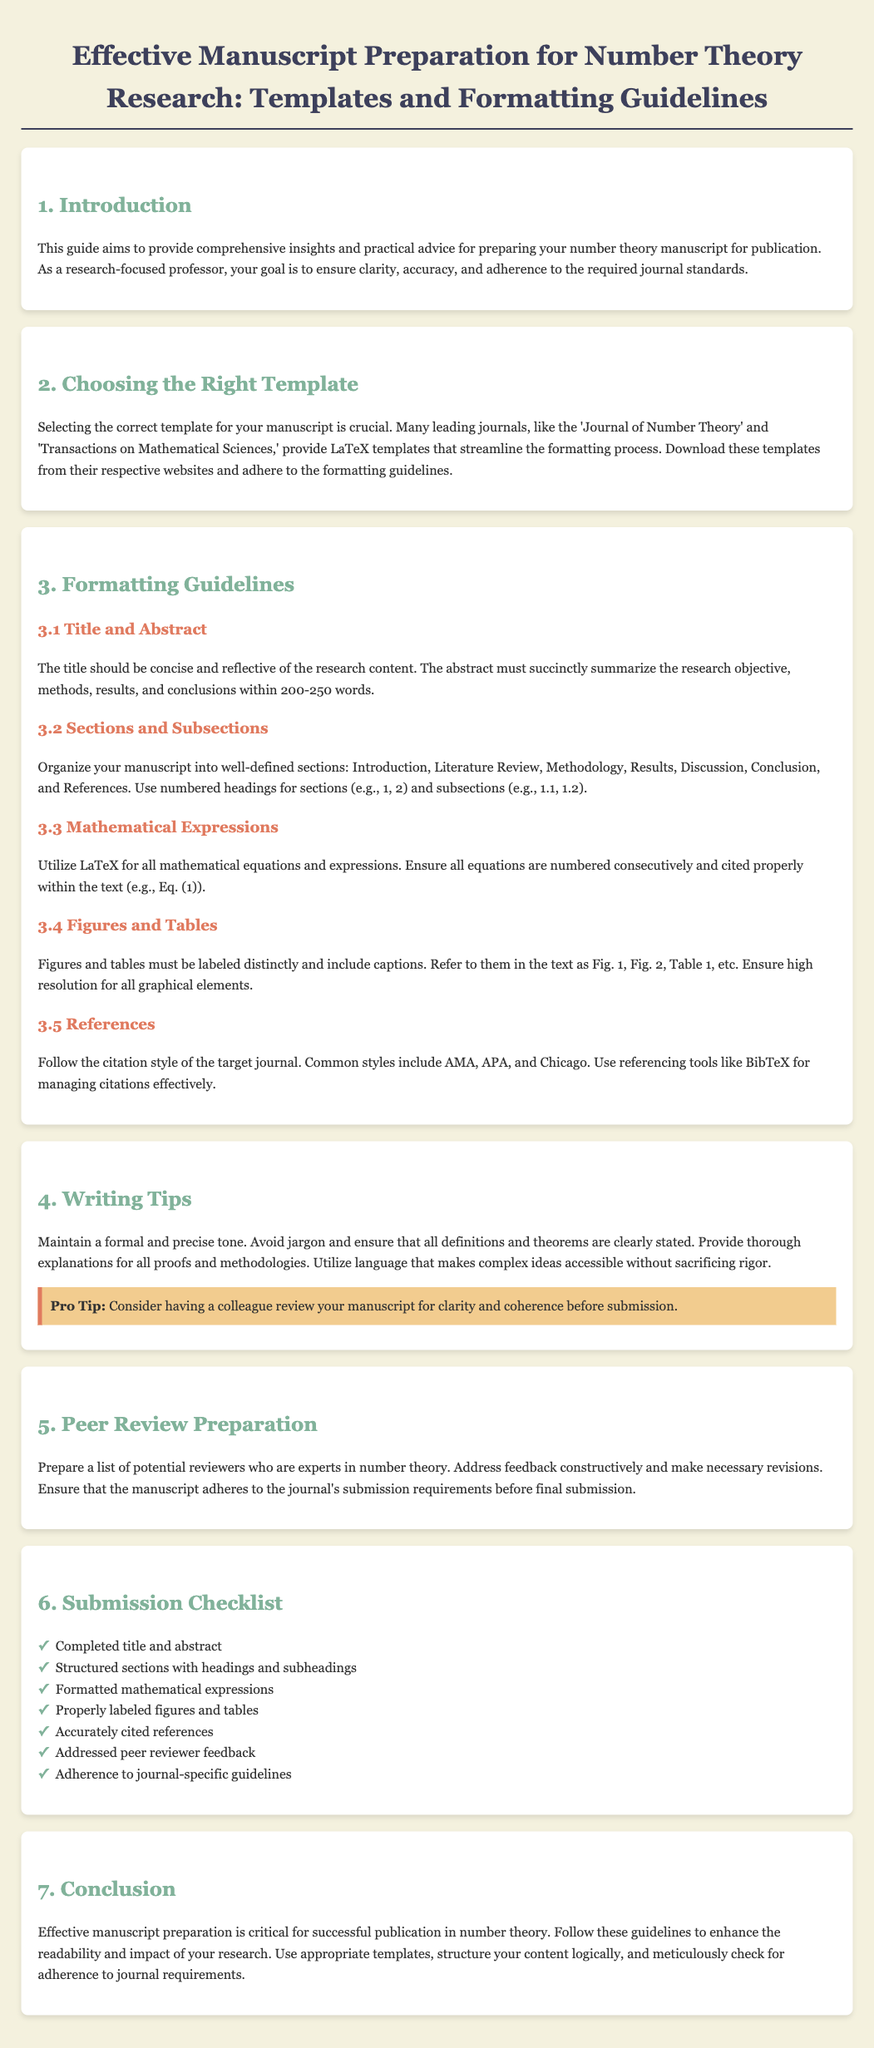What is the title of the document? The title of the document is located in the main heading and describes the content of the guide for manuscript preparation.
Answer: Effective Manuscript Preparation for Number Theory Research: Templates and Formatting Guidelines What is the recommended word count for the abstract? The document specifies a word limit for the abstract, which summarizes the key aspects of the research.
Answer: 200-250 words Which section outlines the formatting for mathematical expressions? The section specifically addressing the formatting of mathematical content in the manuscript is clearly numbered in the guidelines.
Answer: 3.3 Mathematical Expressions What is one tip provided for writing? The writing section offers practical advice on improving manuscript clarity and coherence.
Answer: Have a colleague review your manuscript What style guides are mentioned for reference formatting? The reference formatting section outlines commonly used styles in scholarly writing, indicating their use in citations.
Answer: AMA, APA, and Chicago What is the last section of the document? The document is organized systematically, ending with a summary of key points regarding manuscript preparation.
Answer: 7. Conclusion How many main sections are in the document? The introduction outlines the structure of the document, allowing us to count the distinct sections listed.
Answer: 7 What is the background color of the document? The styling element of the document describes the overall visual theme, including background color.
Answer: #f4f1de 